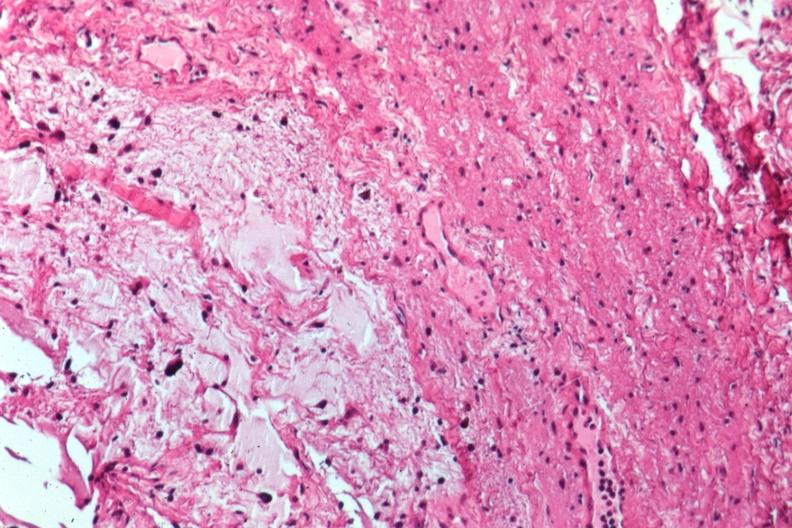what does this image show?
Answer the question using a single word or phrase. Glioma 